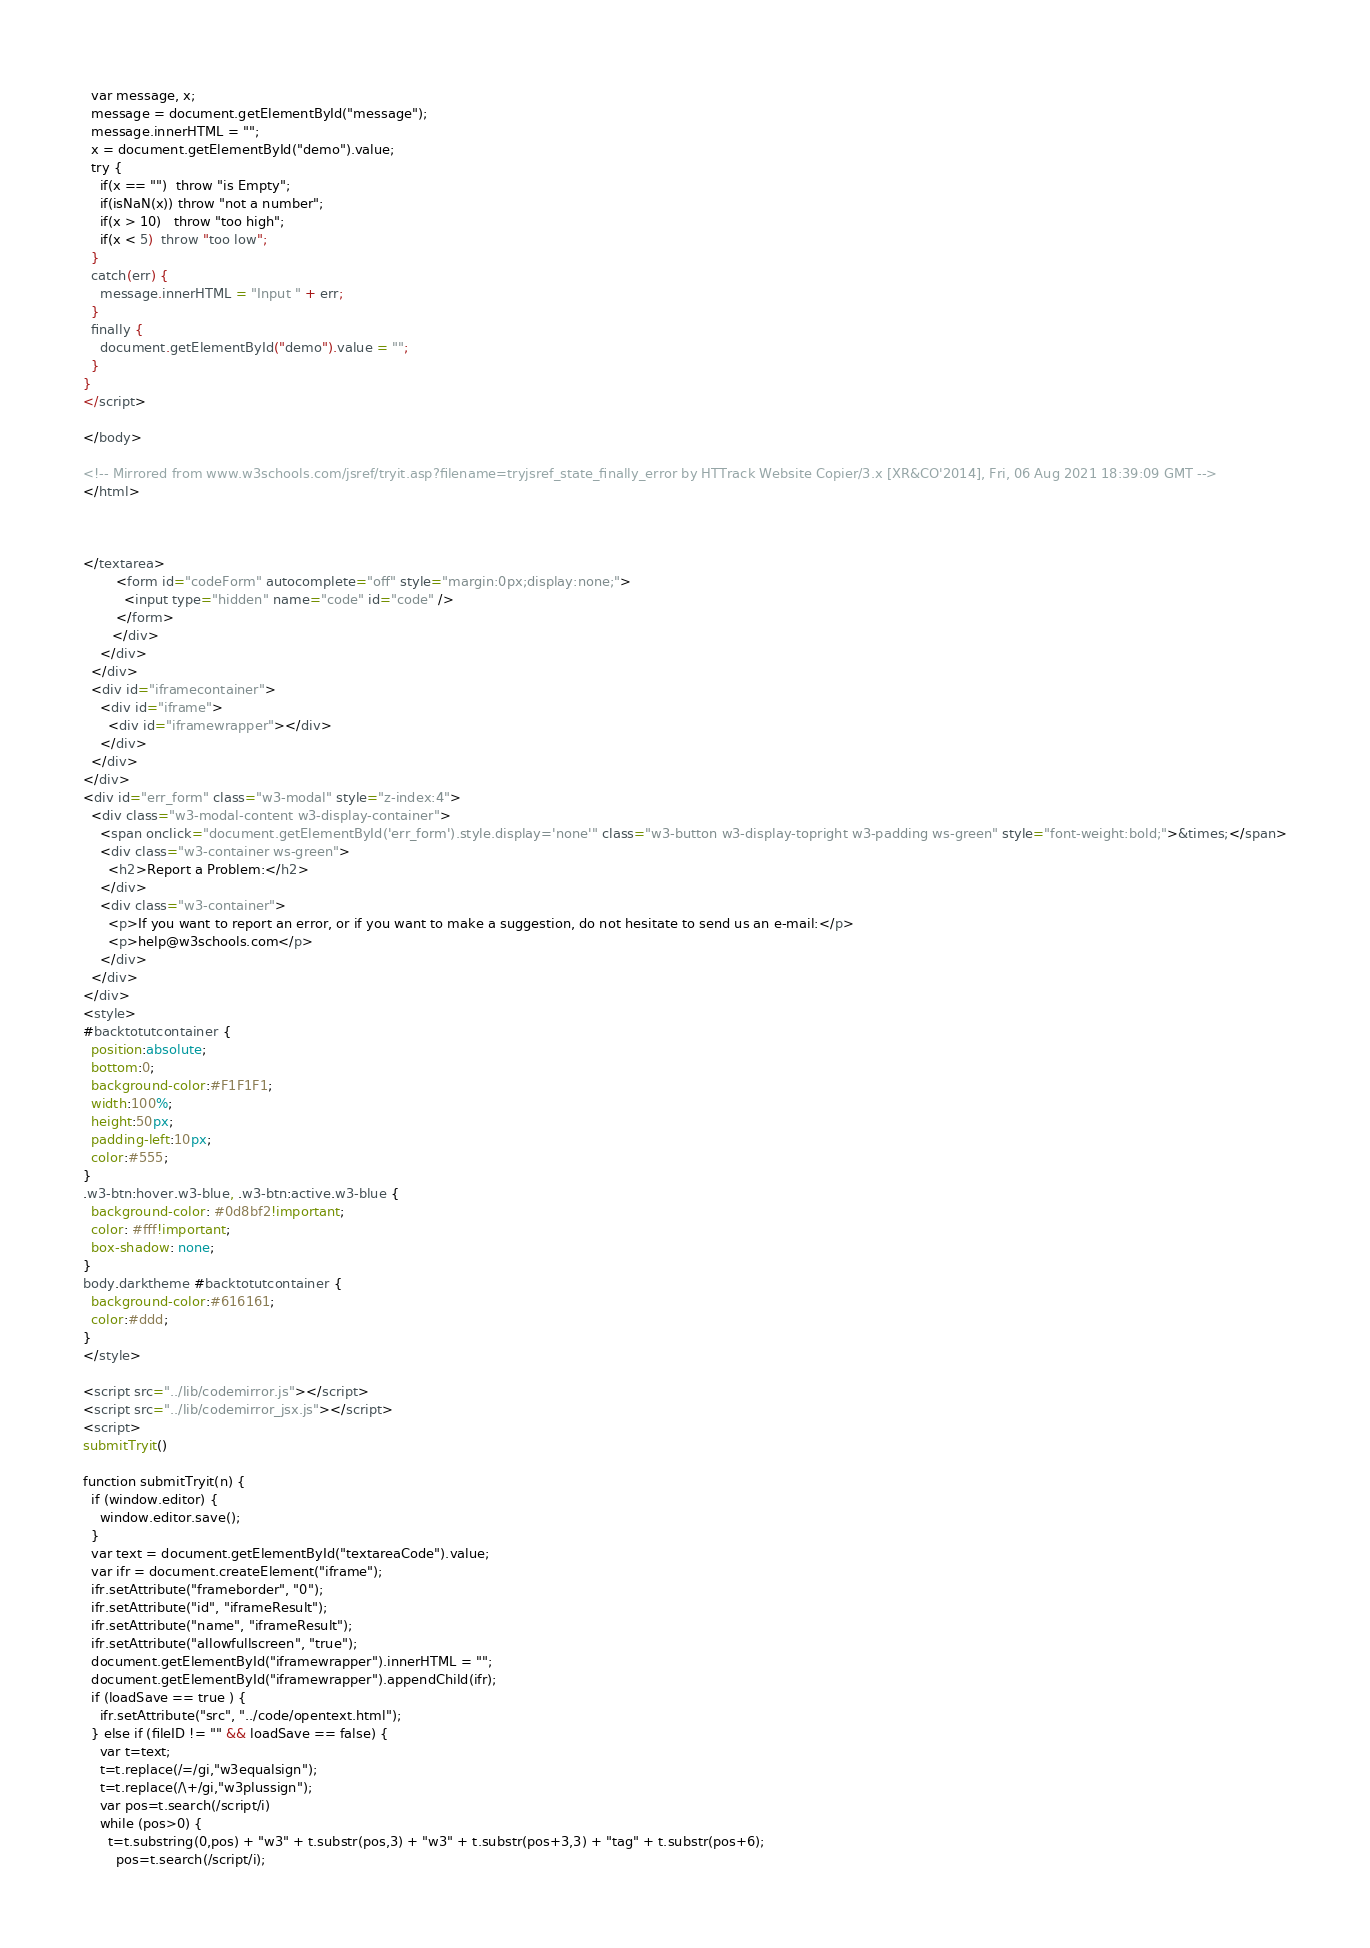<code> <loc_0><loc_0><loc_500><loc_500><_HTML_>  var message, x;
  message = document.getElementById("message");
  message.innerHTML = "";
  x = document.getElementById("demo").value;
  try { 
    if(x == "")  throw "is Empty";
    if(isNaN(x)) throw "not a number";
    if(x > 10)   throw "too high";
    if(x < 5)  throw "too low";
  }
  catch(err) {
    message.innerHTML = "Input " + err;
  }
  finally {
    document.getElementById("demo").value = "";
  }
}
</script>

</body>

<!-- Mirrored from www.w3schools.com/jsref/tryit.asp?filename=tryjsref_state_finally_error by HTTrack Website Copier/3.x [XR&CO'2014], Fri, 06 Aug 2021 18:39:09 GMT -->
</html>



</textarea>
        <form id="codeForm" autocomplete="off" style="margin:0px;display:none;">
          <input type="hidden" name="code" id="code" />
        </form>
       </div>
    </div>
  </div>
  <div id="iframecontainer">
    <div id="iframe">
      <div id="iframewrapper"></div>
    </div>
  </div>
</div>
<div id="err_form" class="w3-modal" style="z-index:4">
  <div class="w3-modal-content w3-display-container">
    <span onclick="document.getElementById('err_form').style.display='none'" class="w3-button w3-display-topright w3-padding ws-green" style="font-weight:bold;">&times;</span>
    <div class="w3-container ws-green">
      <h2>Report a Problem:</h2>
    </div>
    <div class="w3-container"> 
      <p>If you want to report an error, or if you want to make a suggestion, do not hesitate to send us an e-mail:</p>
      <p>help@w3schools.com</p>
    </div>
  </div>
</div>
<style>
#backtotutcontainer {
  position:absolute;
  bottom:0;
  background-color:#F1F1F1;
  width:100%;
  height:50px;
  padding-left:10px;
  color:#555;
}
.w3-btn:hover.w3-blue, .w3-btn:active.w3-blue {
  background-color: #0d8bf2!important;
  color: #fff!important;
  box-shadow: none;
}
body.darktheme #backtotutcontainer {
  background-color:#616161;
  color:#ddd;
}
</style>

<script src="../lib/codemirror.js"></script>
<script src="../lib/codemirror_jsx.js"></script>
<script>
submitTryit()

function submitTryit(n) {
  if (window.editor) {
    window.editor.save();
  }
  var text = document.getElementById("textareaCode").value;
  var ifr = document.createElement("iframe");
  ifr.setAttribute("frameborder", "0");
  ifr.setAttribute("id", "iframeResult");
  ifr.setAttribute("name", "iframeResult");  
  ifr.setAttribute("allowfullscreen", "true");  
  document.getElementById("iframewrapper").innerHTML = "";
  document.getElementById("iframewrapper").appendChild(ifr);
  if (loadSave == true ) {
    ifr.setAttribute("src", "../code/opentext.html");
  } else if (fileID != "" && loadSave == false) {
    var t=text;
    t=t.replace(/=/gi,"w3equalsign");
    t=t.replace(/\+/gi,"w3plussign");    
    var pos=t.search(/script/i)
    while (pos>0) {
      t=t.substring(0,pos) + "w3" + t.substr(pos,3) + "w3" + t.substr(pos+3,3) + "tag" + t.substr(pos+6);
	    pos=t.search(/script/i);</code> 